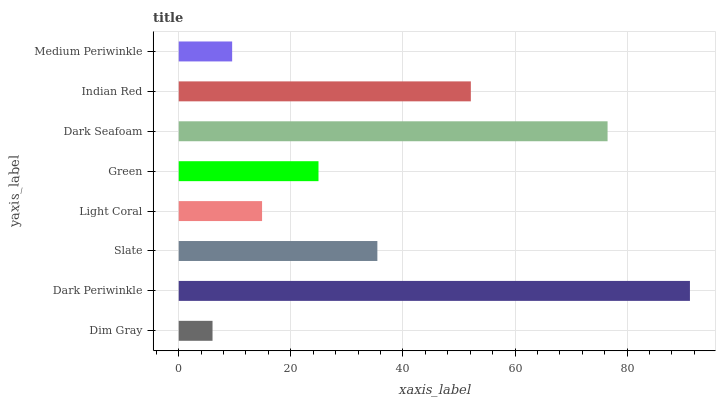Is Dim Gray the minimum?
Answer yes or no. Yes. Is Dark Periwinkle the maximum?
Answer yes or no. Yes. Is Slate the minimum?
Answer yes or no. No. Is Slate the maximum?
Answer yes or no. No. Is Dark Periwinkle greater than Slate?
Answer yes or no. Yes. Is Slate less than Dark Periwinkle?
Answer yes or no. Yes. Is Slate greater than Dark Periwinkle?
Answer yes or no. No. Is Dark Periwinkle less than Slate?
Answer yes or no. No. Is Slate the high median?
Answer yes or no. Yes. Is Green the low median?
Answer yes or no. Yes. Is Green the high median?
Answer yes or no. No. Is Light Coral the low median?
Answer yes or no. No. 